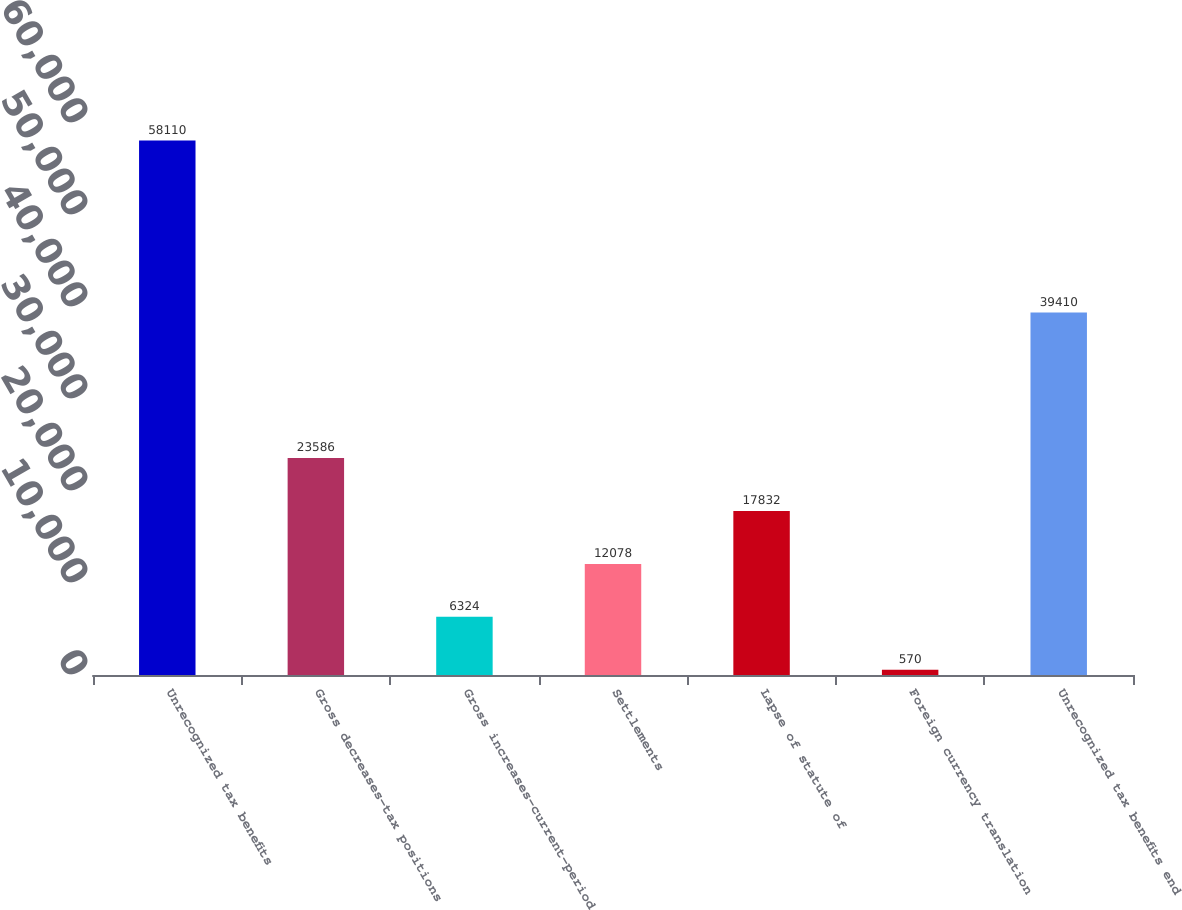<chart> <loc_0><loc_0><loc_500><loc_500><bar_chart><fcel>Unrecognized tax benefits<fcel>Gross decreases-tax positions<fcel>Gross increases-current-period<fcel>Settlements<fcel>Lapse of statute of<fcel>Foreign currency translation<fcel>Unrecognized tax benefits end<nl><fcel>58110<fcel>23586<fcel>6324<fcel>12078<fcel>17832<fcel>570<fcel>39410<nl></chart> 